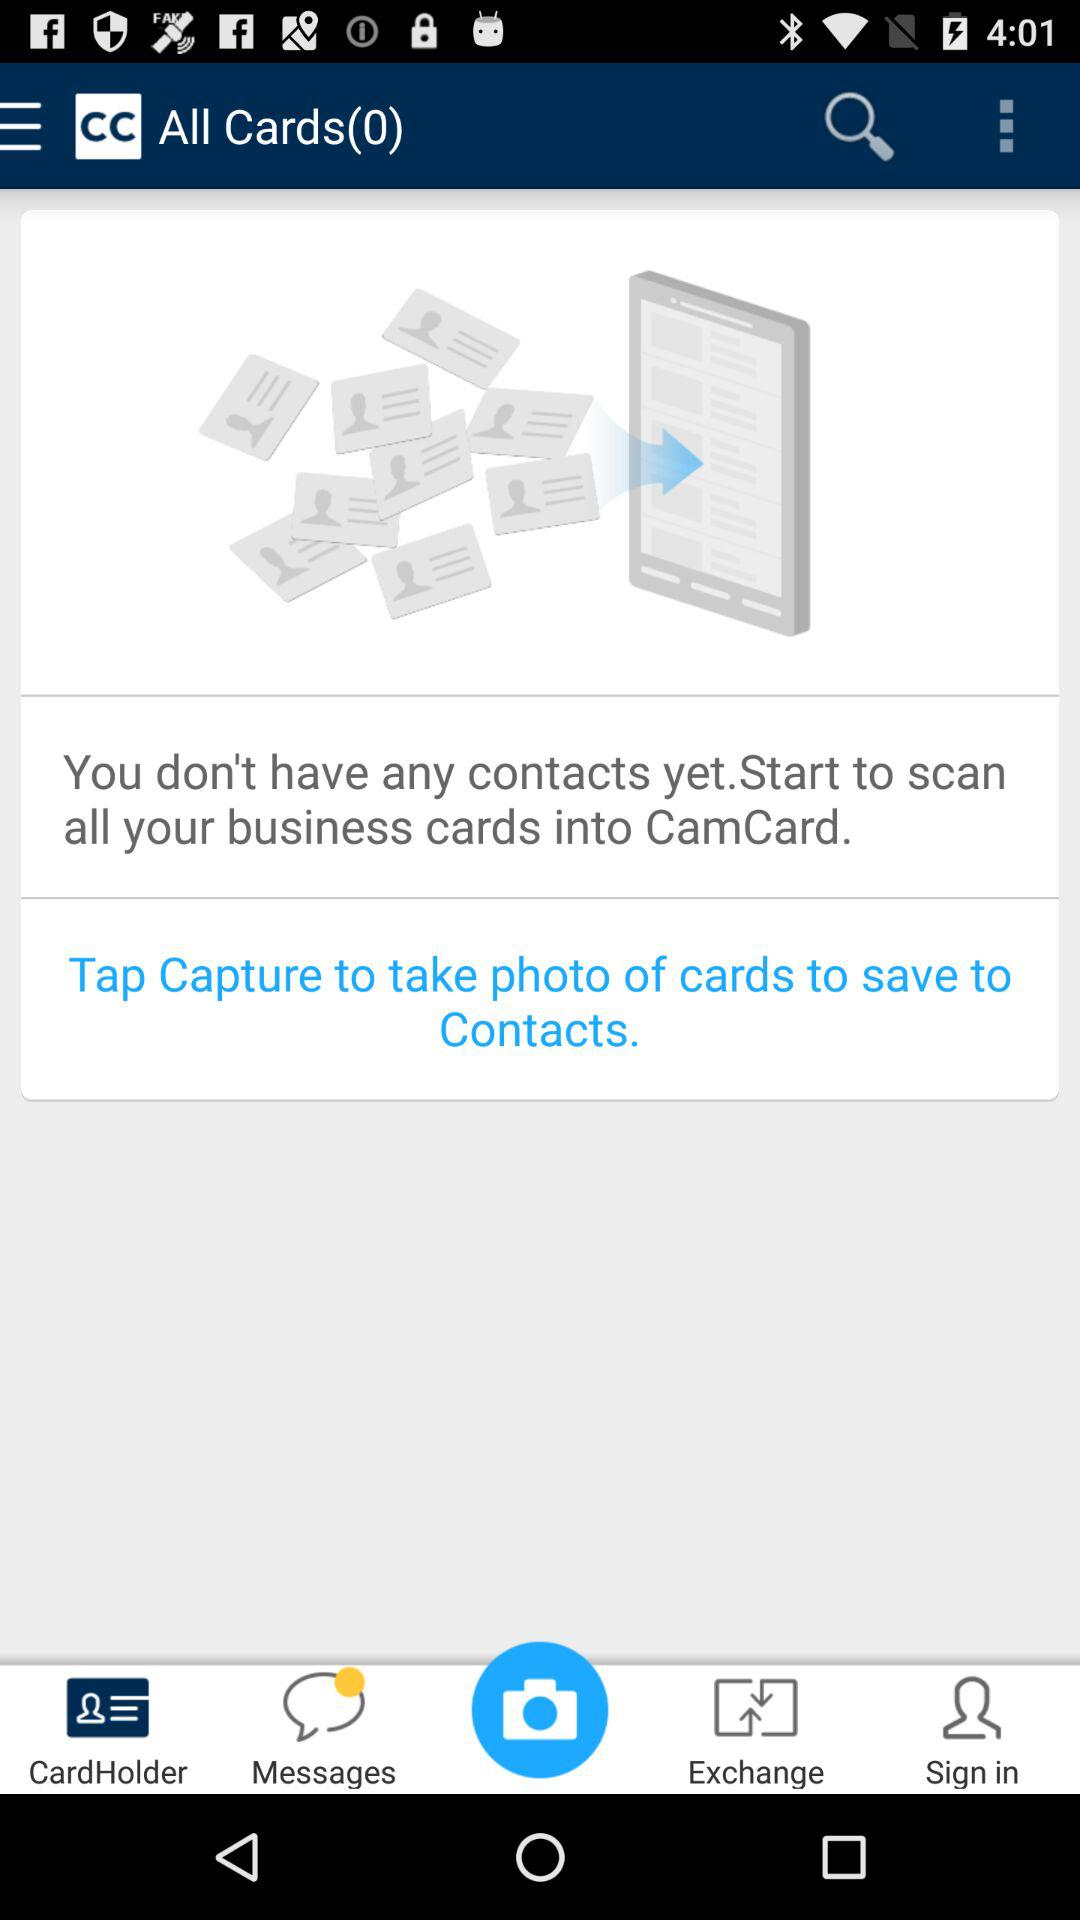How many cards are there? There are 0 cards. 